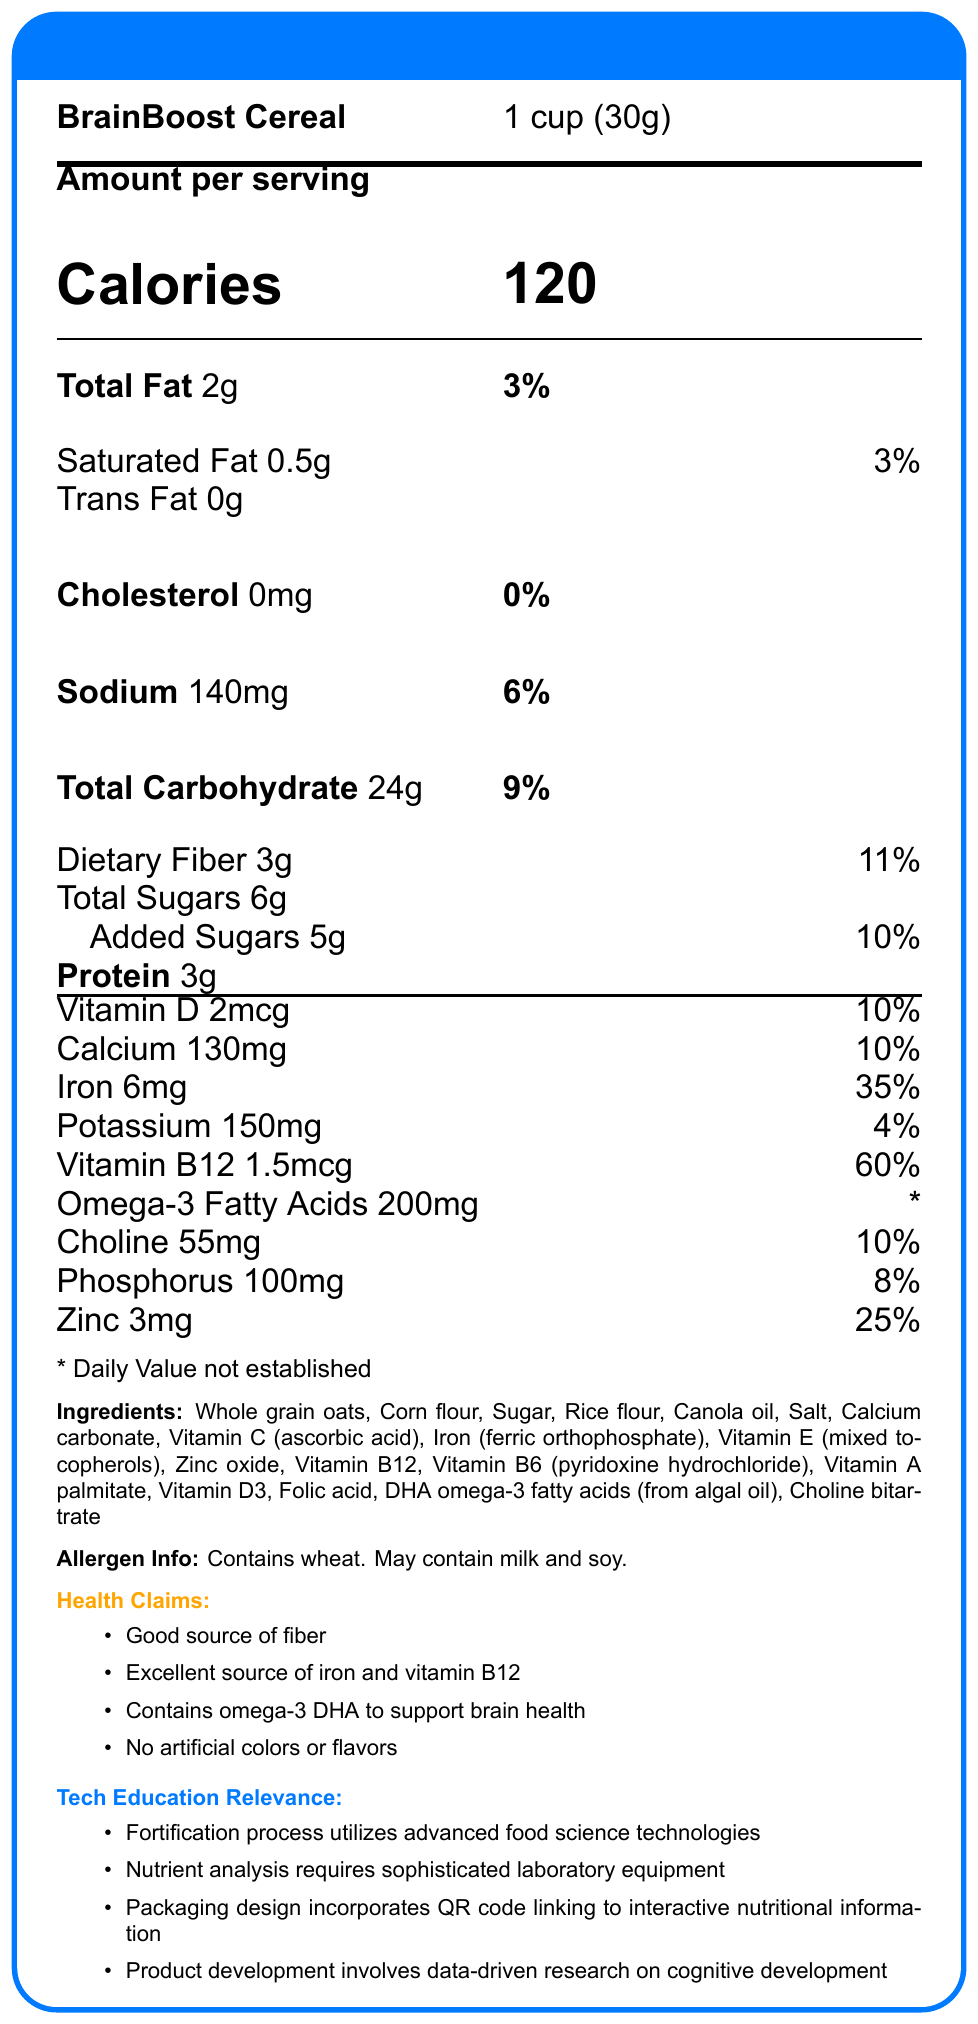What is the serving size for BrainBoost Cereal? The serving size information is located at the top of the nutrition facts, under the product name, and is specified as "1 cup (30g)".
Answer: 1 cup (30g) How many servings are in each container of BrainBoost Cereal? This information is found next to the serving size and product name at the top of the nutrition facts document.
Answer: About 12 What is the total amount of calories per serving? The calorie information is prominently displayed in large font and is labeled as 120 calories per serving.
Answer: 120 What is the percentage of daily value for iron in one serving? The daily value percentage for iron is listed under the nutrients section and marked as 35%.
Answer: 35% What ingredient contributes omega-3 DHA to the product? This information is listed in the ingredients section.
Answer: DHA omega-3 fatty acids (from algal oil) Which technology is mentioned in the fortification process of the cereal? A. Genetic modification B. Advanced food science technologies C. Electrophoresis The document states that the fortification process utilizes "advanced food science technologies".
Answer: B What is the daily value percentage of Vitamin B12 in BrainBoost Cereal? A. 60% B. 25% C. 35% D. 20% The daily value percentage for Vitamin B12 is listed as 60%.
Answer: A Does the cereal contain any artificial colors or flavors? One of the health claims explicitly states that the product contains "No artificial colors or flavors".
Answer: No Is BrainBoost Cereal a good source of fiber? This is indicated under the health claims section where it states "Good source of fiber".
Answer: Yes Describe the main idea of the Nutrition Facts Label for BrainBoost Cereal. This summary covers the primary focus of the document, blending the nutritional benefits with the related technological aspects.
Answer: BrainBoost Cereal is a fortified breakfast cereal that emphasizes supporting children's cognitive development through its nutritional composition, including omega-3 DHA, abundant iron, and vitamin B12. It also highlights the advanced food science technologies used in its fortification process, sophisticated nutrient analysis methods, interactive packaging design, and data-driven product development focused on brain health. How much dietary fiber is in one serving of BrainBoost Cereal? The dietary fiber content is listed as 3g, under the total carbohydrate section.
Answer: 3g What are some health claims made about BrainBoost Cereal? These are the health claims explicitly detailed in the document.
Answer: Good source of fiber, Excellent source of iron and vitamin B12, Contains omega-3 DHA to support brain health, No artificial colors or flavors What is the fortification process of the cereal linked to in terms of education? The document explicitly mentions the fortification process utilizes advanced food science technologies, highlighting its relevance to technology education.
Answer: Advanced food science technologies Can the exact process of fortification be determined from the label? The label mentions the use of advanced food science technologies but does not provide specific details about the fortification process.
Answer: Cannot be determined Is there any indication of milk or soy allergens being present in BrainBoost Cereal? The allergen info section states that the cereal “may contain milk and soy”.
Answer: Yes What is the total amount of added sugars in a serving of BrainBoost Cereal? The added sugars content is listed as 5g under the total sugars section.
Answer: 5g What is one key technology education relevance mentioned in the document? This is one of the bullet points listed under the "Tech Education Relevance" section of the document.
Answer: Nutrient analysis requires sophisticated laboratory equipment 